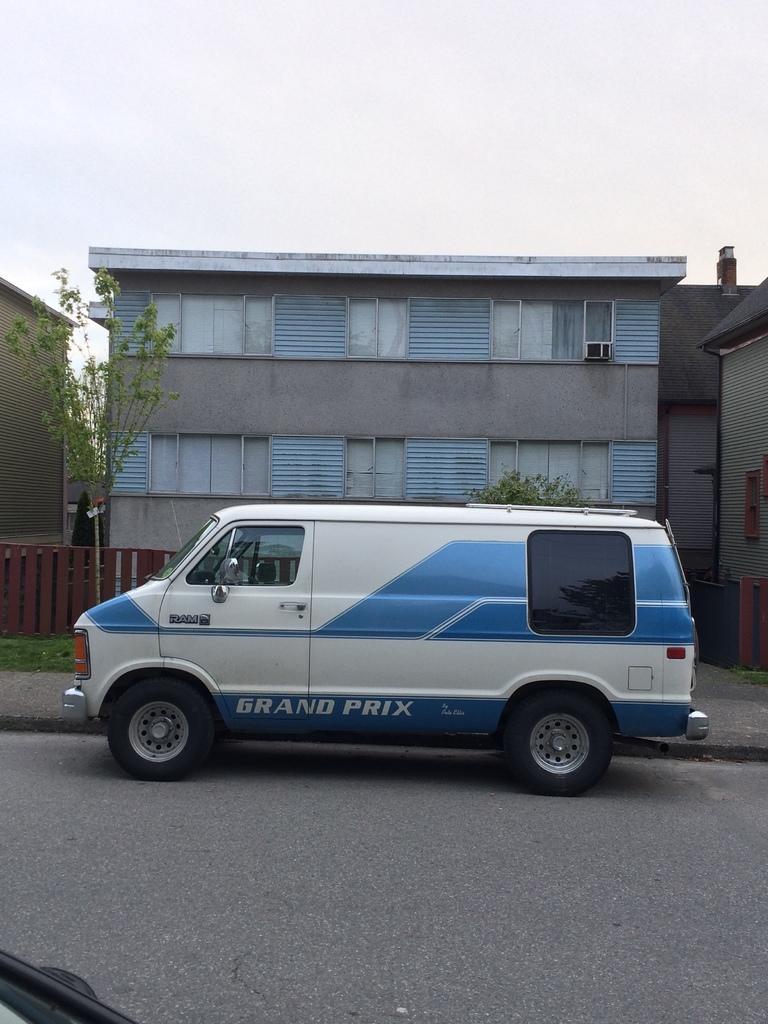In one or two sentences, can you explain what this image depicts? In this image we can see few buildings and they are having few windows. There are few plants in the image. We can see the sky in the image. There is a grassy land in the image. There is a vehicle on the road. We can see the reflection of a tree on the glass of a vehicle. There is an object at the bottom right corner of the image. 